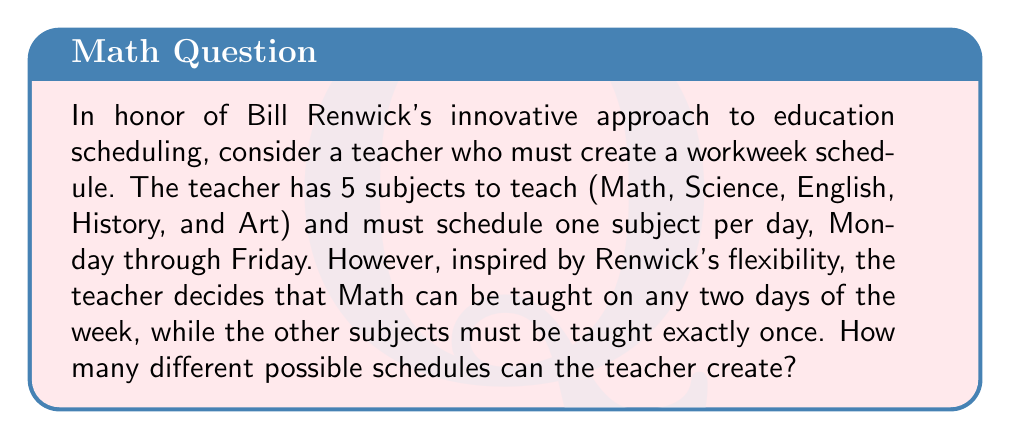Solve this math problem. Let's approach this step-by-step:

1) First, we need to choose the two days for Math. We can select 2 days out of 5, which can be calculated using the combination formula:

   $$\binom{5}{2} = \frac{5!}{2!(5-2)!} = \frac{5 \cdot 4}{2 \cdot 1} = 10$$

2) After placing Math, we have 3 days left to fill with the remaining 3 subjects (Science, English, and History). Art will automatically fill the last remaining day.

3) For these 3 subjects, we need to consider their permutations. This can be calculated as:

   $$3! = 3 \cdot 2 \cdot 1 = 6$$

4) By the multiplication principle, the total number of possible schedules is the product of the number of ways to place Math and the number of ways to arrange the other subjects:

   $$10 \cdot 6 = 60$$

Therefore, the teacher can create 60 different possible schedules.
Answer: 60 